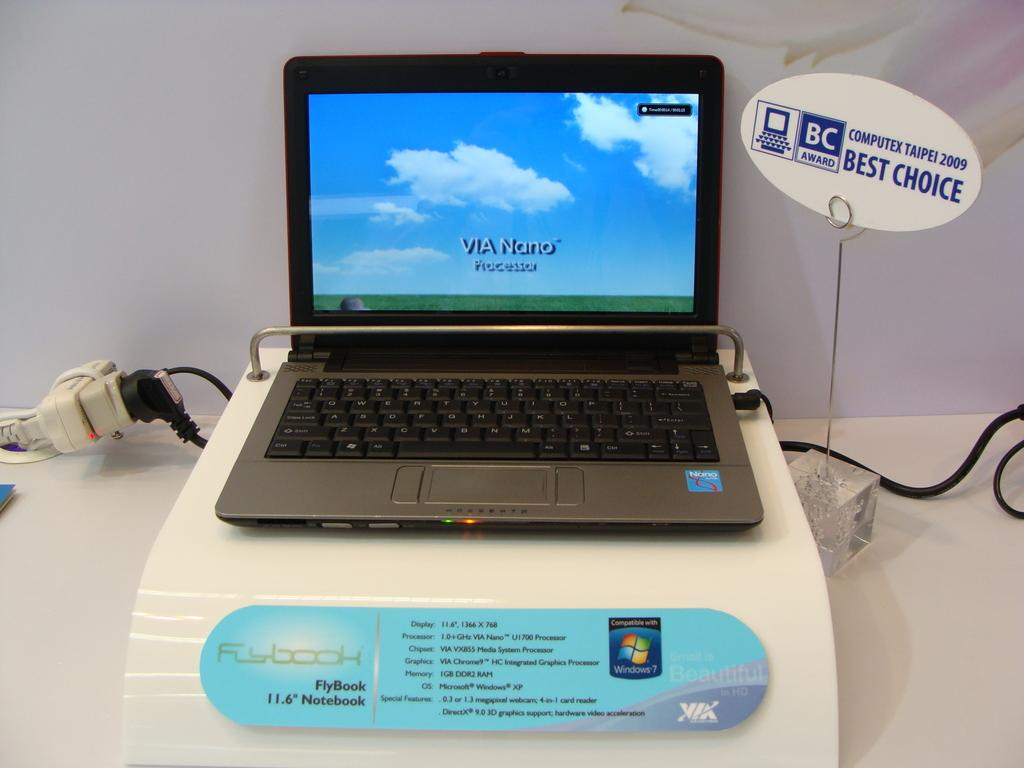Provide a one-sentence caption for the provided image. A FlyBook laptop display shows iots processor name on the screen. 